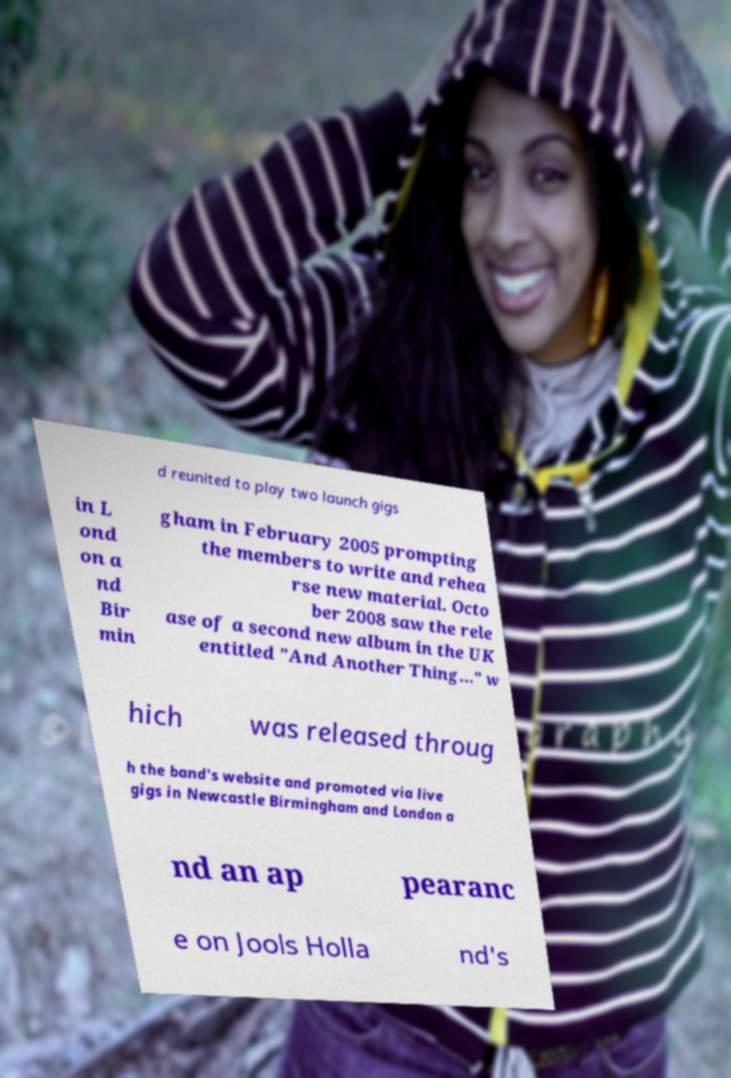Can you accurately transcribe the text from the provided image for me? d reunited to play two launch gigs in L ond on a nd Bir min gham in February 2005 prompting the members to write and rehea rse new material. Octo ber 2008 saw the rele ase of a second new album in the UK entitled "And Another Thing..." w hich was released throug h the band's website and promoted via live gigs in Newcastle Birmingham and London a nd an ap pearanc e on Jools Holla nd's 